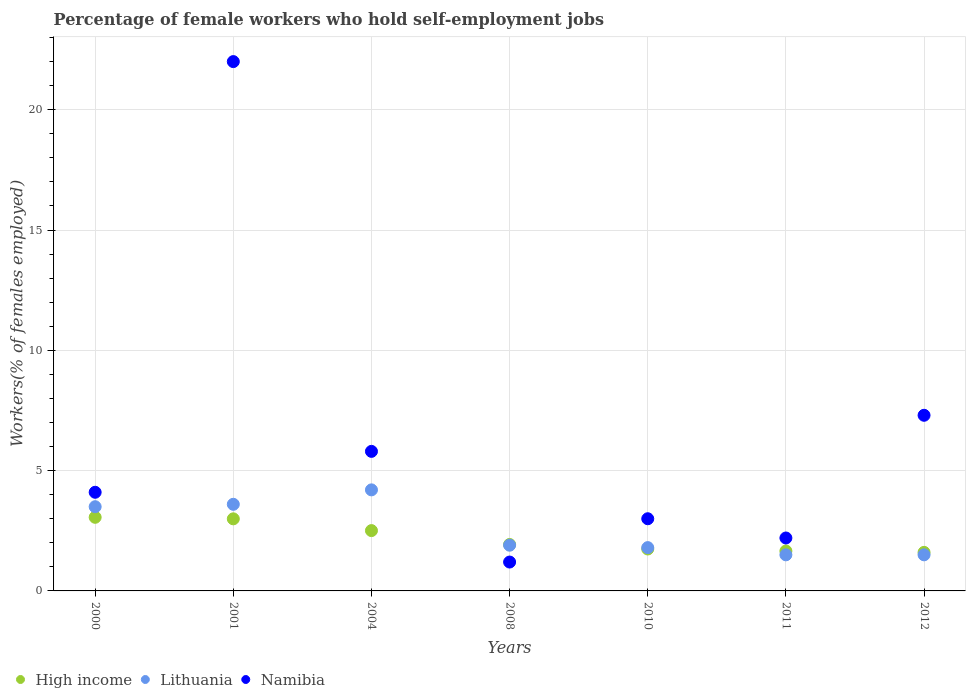What is the percentage of self-employed female workers in High income in 2010?
Provide a succinct answer. 1.74. Across all years, what is the maximum percentage of self-employed female workers in Lithuania?
Keep it short and to the point. 4.2. What is the total percentage of self-employed female workers in Lithuania in the graph?
Your response must be concise. 18. What is the difference between the percentage of self-employed female workers in High income in 2000 and that in 2010?
Give a very brief answer. 1.32. What is the difference between the percentage of self-employed female workers in Lithuania in 2008 and the percentage of self-employed female workers in High income in 2010?
Provide a short and direct response. 0.16. What is the average percentage of self-employed female workers in Lithuania per year?
Make the answer very short. 2.57. In the year 2000, what is the difference between the percentage of self-employed female workers in Lithuania and percentage of self-employed female workers in Namibia?
Provide a succinct answer. -0.6. In how many years, is the percentage of self-employed female workers in Lithuania greater than 13 %?
Give a very brief answer. 0. What is the ratio of the percentage of self-employed female workers in Lithuania in 2000 to that in 2001?
Give a very brief answer. 0.97. What is the difference between the highest and the second highest percentage of self-employed female workers in High income?
Offer a very short reply. 0.06. What is the difference between the highest and the lowest percentage of self-employed female workers in Namibia?
Provide a short and direct response. 20.8. Is it the case that in every year, the sum of the percentage of self-employed female workers in Namibia and percentage of self-employed female workers in High income  is greater than the percentage of self-employed female workers in Lithuania?
Ensure brevity in your answer.  Yes. Does the percentage of self-employed female workers in High income monotonically increase over the years?
Offer a very short reply. No. Is the percentage of self-employed female workers in Namibia strictly greater than the percentage of self-employed female workers in High income over the years?
Ensure brevity in your answer.  No. Are the values on the major ticks of Y-axis written in scientific E-notation?
Offer a terse response. No. Does the graph contain any zero values?
Provide a short and direct response. No. What is the title of the graph?
Your answer should be compact. Percentage of female workers who hold self-employment jobs. What is the label or title of the X-axis?
Offer a very short reply. Years. What is the label or title of the Y-axis?
Your answer should be very brief. Workers(% of females employed). What is the Workers(% of females employed) in High income in 2000?
Offer a terse response. 3.06. What is the Workers(% of females employed) of Namibia in 2000?
Give a very brief answer. 4.1. What is the Workers(% of females employed) of High income in 2001?
Your answer should be very brief. 3. What is the Workers(% of females employed) of Lithuania in 2001?
Make the answer very short. 3.6. What is the Workers(% of females employed) in High income in 2004?
Make the answer very short. 2.51. What is the Workers(% of females employed) in Lithuania in 2004?
Offer a terse response. 4.2. What is the Workers(% of females employed) in Namibia in 2004?
Provide a succinct answer. 5.8. What is the Workers(% of females employed) of High income in 2008?
Provide a succinct answer. 1.93. What is the Workers(% of females employed) of Lithuania in 2008?
Keep it short and to the point. 1.9. What is the Workers(% of females employed) in Namibia in 2008?
Provide a succinct answer. 1.2. What is the Workers(% of females employed) in High income in 2010?
Give a very brief answer. 1.74. What is the Workers(% of females employed) of Lithuania in 2010?
Provide a succinct answer. 1.8. What is the Workers(% of females employed) in High income in 2011?
Keep it short and to the point. 1.66. What is the Workers(% of females employed) of Lithuania in 2011?
Offer a very short reply. 1.5. What is the Workers(% of females employed) of Namibia in 2011?
Provide a short and direct response. 2.2. What is the Workers(% of females employed) in High income in 2012?
Your response must be concise. 1.6. What is the Workers(% of females employed) in Lithuania in 2012?
Your answer should be compact. 1.5. What is the Workers(% of females employed) in Namibia in 2012?
Your answer should be compact. 7.3. Across all years, what is the maximum Workers(% of females employed) of High income?
Give a very brief answer. 3.06. Across all years, what is the maximum Workers(% of females employed) of Lithuania?
Make the answer very short. 4.2. Across all years, what is the minimum Workers(% of females employed) in High income?
Make the answer very short. 1.6. Across all years, what is the minimum Workers(% of females employed) of Namibia?
Offer a very short reply. 1.2. What is the total Workers(% of females employed) in High income in the graph?
Your answer should be very brief. 15.5. What is the total Workers(% of females employed) of Lithuania in the graph?
Offer a very short reply. 18. What is the total Workers(% of females employed) of Namibia in the graph?
Provide a short and direct response. 45.6. What is the difference between the Workers(% of females employed) in High income in 2000 and that in 2001?
Keep it short and to the point. 0.06. What is the difference between the Workers(% of females employed) of Lithuania in 2000 and that in 2001?
Provide a succinct answer. -0.1. What is the difference between the Workers(% of females employed) of Namibia in 2000 and that in 2001?
Make the answer very short. -17.9. What is the difference between the Workers(% of females employed) in High income in 2000 and that in 2004?
Make the answer very short. 0.55. What is the difference between the Workers(% of females employed) of Namibia in 2000 and that in 2004?
Your response must be concise. -1.7. What is the difference between the Workers(% of females employed) in High income in 2000 and that in 2008?
Offer a terse response. 1.13. What is the difference between the Workers(% of females employed) in Lithuania in 2000 and that in 2008?
Offer a very short reply. 1.6. What is the difference between the Workers(% of females employed) of Namibia in 2000 and that in 2008?
Offer a terse response. 2.9. What is the difference between the Workers(% of females employed) of High income in 2000 and that in 2010?
Give a very brief answer. 1.32. What is the difference between the Workers(% of females employed) of Lithuania in 2000 and that in 2010?
Your response must be concise. 1.7. What is the difference between the Workers(% of females employed) of Namibia in 2000 and that in 2010?
Offer a terse response. 1.1. What is the difference between the Workers(% of females employed) in High income in 2000 and that in 2011?
Keep it short and to the point. 1.4. What is the difference between the Workers(% of females employed) of High income in 2000 and that in 2012?
Provide a short and direct response. 1.46. What is the difference between the Workers(% of females employed) of Lithuania in 2000 and that in 2012?
Offer a terse response. 2. What is the difference between the Workers(% of females employed) in High income in 2001 and that in 2004?
Your answer should be compact. 0.49. What is the difference between the Workers(% of females employed) of Namibia in 2001 and that in 2004?
Make the answer very short. 16.2. What is the difference between the Workers(% of females employed) of High income in 2001 and that in 2008?
Offer a very short reply. 1.07. What is the difference between the Workers(% of females employed) in Lithuania in 2001 and that in 2008?
Make the answer very short. 1.7. What is the difference between the Workers(% of females employed) of Namibia in 2001 and that in 2008?
Give a very brief answer. 20.8. What is the difference between the Workers(% of females employed) of High income in 2001 and that in 2010?
Your answer should be compact. 1.25. What is the difference between the Workers(% of females employed) in Lithuania in 2001 and that in 2010?
Your response must be concise. 1.8. What is the difference between the Workers(% of females employed) in Namibia in 2001 and that in 2010?
Offer a terse response. 19. What is the difference between the Workers(% of females employed) in High income in 2001 and that in 2011?
Provide a short and direct response. 1.34. What is the difference between the Workers(% of females employed) in Lithuania in 2001 and that in 2011?
Keep it short and to the point. 2.1. What is the difference between the Workers(% of females employed) in Namibia in 2001 and that in 2011?
Your response must be concise. 19.8. What is the difference between the Workers(% of females employed) in High income in 2001 and that in 2012?
Offer a terse response. 1.39. What is the difference between the Workers(% of females employed) of Namibia in 2001 and that in 2012?
Offer a very short reply. 14.7. What is the difference between the Workers(% of females employed) of High income in 2004 and that in 2008?
Your response must be concise. 0.58. What is the difference between the Workers(% of females employed) of High income in 2004 and that in 2010?
Your response must be concise. 0.76. What is the difference between the Workers(% of females employed) of High income in 2004 and that in 2011?
Your answer should be compact. 0.85. What is the difference between the Workers(% of females employed) in Namibia in 2004 and that in 2011?
Give a very brief answer. 3.6. What is the difference between the Workers(% of females employed) in High income in 2004 and that in 2012?
Give a very brief answer. 0.9. What is the difference between the Workers(% of females employed) of High income in 2008 and that in 2010?
Your answer should be compact. 0.19. What is the difference between the Workers(% of females employed) in High income in 2008 and that in 2011?
Keep it short and to the point. 0.27. What is the difference between the Workers(% of females employed) in Lithuania in 2008 and that in 2011?
Provide a short and direct response. 0.4. What is the difference between the Workers(% of females employed) in High income in 2008 and that in 2012?
Provide a succinct answer. 0.33. What is the difference between the Workers(% of females employed) of High income in 2010 and that in 2011?
Give a very brief answer. 0.08. What is the difference between the Workers(% of females employed) in Lithuania in 2010 and that in 2011?
Ensure brevity in your answer.  0.3. What is the difference between the Workers(% of females employed) of High income in 2010 and that in 2012?
Offer a terse response. 0.14. What is the difference between the Workers(% of females employed) in Lithuania in 2010 and that in 2012?
Your response must be concise. 0.3. What is the difference between the Workers(% of females employed) in Namibia in 2010 and that in 2012?
Make the answer very short. -4.3. What is the difference between the Workers(% of females employed) in High income in 2011 and that in 2012?
Provide a succinct answer. 0.06. What is the difference between the Workers(% of females employed) of High income in 2000 and the Workers(% of females employed) of Lithuania in 2001?
Provide a succinct answer. -0.54. What is the difference between the Workers(% of females employed) of High income in 2000 and the Workers(% of females employed) of Namibia in 2001?
Offer a terse response. -18.94. What is the difference between the Workers(% of females employed) of Lithuania in 2000 and the Workers(% of females employed) of Namibia in 2001?
Give a very brief answer. -18.5. What is the difference between the Workers(% of females employed) of High income in 2000 and the Workers(% of females employed) of Lithuania in 2004?
Give a very brief answer. -1.14. What is the difference between the Workers(% of females employed) of High income in 2000 and the Workers(% of females employed) of Namibia in 2004?
Keep it short and to the point. -2.74. What is the difference between the Workers(% of females employed) in Lithuania in 2000 and the Workers(% of females employed) in Namibia in 2004?
Give a very brief answer. -2.3. What is the difference between the Workers(% of females employed) of High income in 2000 and the Workers(% of females employed) of Lithuania in 2008?
Offer a terse response. 1.16. What is the difference between the Workers(% of females employed) of High income in 2000 and the Workers(% of females employed) of Namibia in 2008?
Offer a terse response. 1.86. What is the difference between the Workers(% of females employed) in High income in 2000 and the Workers(% of females employed) in Lithuania in 2010?
Give a very brief answer. 1.26. What is the difference between the Workers(% of females employed) of High income in 2000 and the Workers(% of females employed) of Namibia in 2010?
Your response must be concise. 0.06. What is the difference between the Workers(% of females employed) in Lithuania in 2000 and the Workers(% of females employed) in Namibia in 2010?
Ensure brevity in your answer.  0.5. What is the difference between the Workers(% of females employed) of High income in 2000 and the Workers(% of females employed) of Lithuania in 2011?
Your response must be concise. 1.56. What is the difference between the Workers(% of females employed) of High income in 2000 and the Workers(% of females employed) of Namibia in 2011?
Offer a terse response. 0.86. What is the difference between the Workers(% of females employed) in High income in 2000 and the Workers(% of females employed) in Lithuania in 2012?
Your answer should be compact. 1.56. What is the difference between the Workers(% of females employed) in High income in 2000 and the Workers(% of females employed) in Namibia in 2012?
Ensure brevity in your answer.  -4.24. What is the difference between the Workers(% of females employed) of Lithuania in 2000 and the Workers(% of females employed) of Namibia in 2012?
Provide a succinct answer. -3.8. What is the difference between the Workers(% of females employed) of High income in 2001 and the Workers(% of females employed) of Lithuania in 2004?
Keep it short and to the point. -1.2. What is the difference between the Workers(% of females employed) of High income in 2001 and the Workers(% of females employed) of Namibia in 2004?
Keep it short and to the point. -2.8. What is the difference between the Workers(% of females employed) in High income in 2001 and the Workers(% of females employed) in Lithuania in 2008?
Make the answer very short. 1.1. What is the difference between the Workers(% of females employed) in High income in 2001 and the Workers(% of females employed) in Namibia in 2008?
Provide a succinct answer. 1.8. What is the difference between the Workers(% of females employed) in Lithuania in 2001 and the Workers(% of females employed) in Namibia in 2008?
Make the answer very short. 2.4. What is the difference between the Workers(% of females employed) of High income in 2001 and the Workers(% of females employed) of Lithuania in 2010?
Provide a succinct answer. 1.2. What is the difference between the Workers(% of females employed) in High income in 2001 and the Workers(% of females employed) in Namibia in 2010?
Offer a very short reply. -0. What is the difference between the Workers(% of females employed) in Lithuania in 2001 and the Workers(% of females employed) in Namibia in 2010?
Provide a succinct answer. 0.6. What is the difference between the Workers(% of females employed) of High income in 2001 and the Workers(% of females employed) of Lithuania in 2011?
Provide a succinct answer. 1.5. What is the difference between the Workers(% of females employed) of High income in 2001 and the Workers(% of females employed) of Namibia in 2011?
Make the answer very short. 0.8. What is the difference between the Workers(% of females employed) in Lithuania in 2001 and the Workers(% of females employed) in Namibia in 2011?
Give a very brief answer. 1.4. What is the difference between the Workers(% of females employed) of High income in 2001 and the Workers(% of females employed) of Lithuania in 2012?
Offer a terse response. 1.5. What is the difference between the Workers(% of females employed) of High income in 2001 and the Workers(% of females employed) of Namibia in 2012?
Your response must be concise. -4.3. What is the difference between the Workers(% of females employed) of High income in 2004 and the Workers(% of females employed) of Lithuania in 2008?
Your response must be concise. 0.61. What is the difference between the Workers(% of females employed) in High income in 2004 and the Workers(% of females employed) in Namibia in 2008?
Your response must be concise. 1.31. What is the difference between the Workers(% of females employed) in Lithuania in 2004 and the Workers(% of females employed) in Namibia in 2008?
Make the answer very short. 3. What is the difference between the Workers(% of females employed) of High income in 2004 and the Workers(% of females employed) of Lithuania in 2010?
Offer a terse response. 0.71. What is the difference between the Workers(% of females employed) of High income in 2004 and the Workers(% of females employed) of Namibia in 2010?
Your answer should be very brief. -0.49. What is the difference between the Workers(% of females employed) of Lithuania in 2004 and the Workers(% of females employed) of Namibia in 2010?
Keep it short and to the point. 1.2. What is the difference between the Workers(% of females employed) in High income in 2004 and the Workers(% of females employed) in Lithuania in 2011?
Keep it short and to the point. 1.01. What is the difference between the Workers(% of females employed) of High income in 2004 and the Workers(% of females employed) of Namibia in 2011?
Ensure brevity in your answer.  0.31. What is the difference between the Workers(% of females employed) in Lithuania in 2004 and the Workers(% of females employed) in Namibia in 2011?
Your response must be concise. 2. What is the difference between the Workers(% of females employed) in High income in 2004 and the Workers(% of females employed) in Namibia in 2012?
Your answer should be very brief. -4.79. What is the difference between the Workers(% of females employed) of High income in 2008 and the Workers(% of females employed) of Lithuania in 2010?
Provide a succinct answer. 0.13. What is the difference between the Workers(% of females employed) in High income in 2008 and the Workers(% of females employed) in Namibia in 2010?
Your answer should be very brief. -1.07. What is the difference between the Workers(% of females employed) of Lithuania in 2008 and the Workers(% of females employed) of Namibia in 2010?
Provide a succinct answer. -1.1. What is the difference between the Workers(% of females employed) of High income in 2008 and the Workers(% of females employed) of Lithuania in 2011?
Ensure brevity in your answer.  0.43. What is the difference between the Workers(% of females employed) of High income in 2008 and the Workers(% of females employed) of Namibia in 2011?
Offer a very short reply. -0.27. What is the difference between the Workers(% of females employed) in Lithuania in 2008 and the Workers(% of females employed) in Namibia in 2011?
Provide a succinct answer. -0.3. What is the difference between the Workers(% of females employed) in High income in 2008 and the Workers(% of females employed) in Lithuania in 2012?
Offer a terse response. 0.43. What is the difference between the Workers(% of females employed) in High income in 2008 and the Workers(% of females employed) in Namibia in 2012?
Offer a terse response. -5.37. What is the difference between the Workers(% of females employed) of High income in 2010 and the Workers(% of females employed) of Lithuania in 2011?
Provide a short and direct response. 0.24. What is the difference between the Workers(% of females employed) in High income in 2010 and the Workers(% of females employed) in Namibia in 2011?
Keep it short and to the point. -0.46. What is the difference between the Workers(% of females employed) of High income in 2010 and the Workers(% of females employed) of Lithuania in 2012?
Offer a terse response. 0.24. What is the difference between the Workers(% of females employed) of High income in 2010 and the Workers(% of females employed) of Namibia in 2012?
Provide a succinct answer. -5.56. What is the difference between the Workers(% of females employed) in High income in 2011 and the Workers(% of females employed) in Lithuania in 2012?
Keep it short and to the point. 0.16. What is the difference between the Workers(% of females employed) in High income in 2011 and the Workers(% of females employed) in Namibia in 2012?
Provide a succinct answer. -5.64. What is the difference between the Workers(% of females employed) of Lithuania in 2011 and the Workers(% of females employed) of Namibia in 2012?
Provide a succinct answer. -5.8. What is the average Workers(% of females employed) in High income per year?
Offer a terse response. 2.21. What is the average Workers(% of females employed) of Lithuania per year?
Your answer should be compact. 2.57. What is the average Workers(% of females employed) of Namibia per year?
Your answer should be very brief. 6.51. In the year 2000, what is the difference between the Workers(% of females employed) in High income and Workers(% of females employed) in Lithuania?
Offer a very short reply. -0.44. In the year 2000, what is the difference between the Workers(% of females employed) in High income and Workers(% of females employed) in Namibia?
Make the answer very short. -1.04. In the year 2001, what is the difference between the Workers(% of females employed) of High income and Workers(% of females employed) of Lithuania?
Provide a short and direct response. -0.6. In the year 2001, what is the difference between the Workers(% of females employed) of High income and Workers(% of females employed) of Namibia?
Ensure brevity in your answer.  -19. In the year 2001, what is the difference between the Workers(% of females employed) in Lithuania and Workers(% of females employed) in Namibia?
Your answer should be very brief. -18.4. In the year 2004, what is the difference between the Workers(% of females employed) of High income and Workers(% of females employed) of Lithuania?
Provide a short and direct response. -1.69. In the year 2004, what is the difference between the Workers(% of females employed) in High income and Workers(% of females employed) in Namibia?
Keep it short and to the point. -3.29. In the year 2008, what is the difference between the Workers(% of females employed) of High income and Workers(% of females employed) of Lithuania?
Offer a terse response. 0.03. In the year 2008, what is the difference between the Workers(% of females employed) of High income and Workers(% of females employed) of Namibia?
Provide a short and direct response. 0.73. In the year 2008, what is the difference between the Workers(% of females employed) in Lithuania and Workers(% of females employed) in Namibia?
Offer a terse response. 0.7. In the year 2010, what is the difference between the Workers(% of females employed) of High income and Workers(% of females employed) of Lithuania?
Offer a terse response. -0.06. In the year 2010, what is the difference between the Workers(% of females employed) in High income and Workers(% of females employed) in Namibia?
Make the answer very short. -1.26. In the year 2010, what is the difference between the Workers(% of females employed) in Lithuania and Workers(% of females employed) in Namibia?
Provide a succinct answer. -1.2. In the year 2011, what is the difference between the Workers(% of females employed) in High income and Workers(% of females employed) in Lithuania?
Your response must be concise. 0.16. In the year 2011, what is the difference between the Workers(% of females employed) in High income and Workers(% of females employed) in Namibia?
Your answer should be very brief. -0.54. In the year 2012, what is the difference between the Workers(% of females employed) of High income and Workers(% of females employed) of Lithuania?
Offer a very short reply. 0.1. In the year 2012, what is the difference between the Workers(% of females employed) in High income and Workers(% of females employed) in Namibia?
Provide a short and direct response. -5.7. In the year 2012, what is the difference between the Workers(% of females employed) in Lithuania and Workers(% of females employed) in Namibia?
Offer a very short reply. -5.8. What is the ratio of the Workers(% of females employed) in High income in 2000 to that in 2001?
Ensure brevity in your answer.  1.02. What is the ratio of the Workers(% of females employed) of Lithuania in 2000 to that in 2001?
Offer a very short reply. 0.97. What is the ratio of the Workers(% of females employed) of Namibia in 2000 to that in 2001?
Your response must be concise. 0.19. What is the ratio of the Workers(% of females employed) of High income in 2000 to that in 2004?
Your response must be concise. 1.22. What is the ratio of the Workers(% of females employed) in Lithuania in 2000 to that in 2004?
Your response must be concise. 0.83. What is the ratio of the Workers(% of females employed) in Namibia in 2000 to that in 2004?
Provide a succinct answer. 0.71. What is the ratio of the Workers(% of females employed) of High income in 2000 to that in 2008?
Give a very brief answer. 1.59. What is the ratio of the Workers(% of females employed) of Lithuania in 2000 to that in 2008?
Ensure brevity in your answer.  1.84. What is the ratio of the Workers(% of females employed) of Namibia in 2000 to that in 2008?
Your answer should be compact. 3.42. What is the ratio of the Workers(% of females employed) in High income in 2000 to that in 2010?
Offer a very short reply. 1.76. What is the ratio of the Workers(% of females employed) of Lithuania in 2000 to that in 2010?
Offer a very short reply. 1.94. What is the ratio of the Workers(% of females employed) of Namibia in 2000 to that in 2010?
Your answer should be very brief. 1.37. What is the ratio of the Workers(% of females employed) in High income in 2000 to that in 2011?
Give a very brief answer. 1.84. What is the ratio of the Workers(% of females employed) in Lithuania in 2000 to that in 2011?
Your answer should be compact. 2.33. What is the ratio of the Workers(% of females employed) of Namibia in 2000 to that in 2011?
Offer a very short reply. 1.86. What is the ratio of the Workers(% of females employed) in High income in 2000 to that in 2012?
Provide a succinct answer. 1.91. What is the ratio of the Workers(% of females employed) of Lithuania in 2000 to that in 2012?
Your answer should be compact. 2.33. What is the ratio of the Workers(% of females employed) of Namibia in 2000 to that in 2012?
Keep it short and to the point. 0.56. What is the ratio of the Workers(% of females employed) of High income in 2001 to that in 2004?
Offer a very short reply. 1.2. What is the ratio of the Workers(% of females employed) of Namibia in 2001 to that in 2004?
Provide a succinct answer. 3.79. What is the ratio of the Workers(% of females employed) in High income in 2001 to that in 2008?
Keep it short and to the point. 1.55. What is the ratio of the Workers(% of females employed) of Lithuania in 2001 to that in 2008?
Your response must be concise. 1.89. What is the ratio of the Workers(% of females employed) of Namibia in 2001 to that in 2008?
Ensure brevity in your answer.  18.33. What is the ratio of the Workers(% of females employed) in High income in 2001 to that in 2010?
Offer a very short reply. 1.72. What is the ratio of the Workers(% of females employed) of Namibia in 2001 to that in 2010?
Offer a very short reply. 7.33. What is the ratio of the Workers(% of females employed) in High income in 2001 to that in 2011?
Provide a succinct answer. 1.81. What is the ratio of the Workers(% of females employed) in High income in 2001 to that in 2012?
Offer a terse response. 1.87. What is the ratio of the Workers(% of females employed) of Lithuania in 2001 to that in 2012?
Provide a succinct answer. 2.4. What is the ratio of the Workers(% of females employed) of Namibia in 2001 to that in 2012?
Keep it short and to the point. 3.01. What is the ratio of the Workers(% of females employed) in High income in 2004 to that in 2008?
Offer a terse response. 1.3. What is the ratio of the Workers(% of females employed) of Lithuania in 2004 to that in 2008?
Make the answer very short. 2.21. What is the ratio of the Workers(% of females employed) of Namibia in 2004 to that in 2008?
Offer a terse response. 4.83. What is the ratio of the Workers(% of females employed) in High income in 2004 to that in 2010?
Make the answer very short. 1.44. What is the ratio of the Workers(% of females employed) in Lithuania in 2004 to that in 2010?
Give a very brief answer. 2.33. What is the ratio of the Workers(% of females employed) in Namibia in 2004 to that in 2010?
Your response must be concise. 1.93. What is the ratio of the Workers(% of females employed) in High income in 2004 to that in 2011?
Give a very brief answer. 1.51. What is the ratio of the Workers(% of females employed) in Namibia in 2004 to that in 2011?
Offer a very short reply. 2.64. What is the ratio of the Workers(% of females employed) in High income in 2004 to that in 2012?
Your response must be concise. 1.56. What is the ratio of the Workers(% of females employed) of Lithuania in 2004 to that in 2012?
Your answer should be compact. 2.8. What is the ratio of the Workers(% of females employed) in Namibia in 2004 to that in 2012?
Provide a succinct answer. 0.79. What is the ratio of the Workers(% of females employed) of High income in 2008 to that in 2010?
Keep it short and to the point. 1.11. What is the ratio of the Workers(% of females employed) of Lithuania in 2008 to that in 2010?
Offer a very short reply. 1.06. What is the ratio of the Workers(% of females employed) of High income in 2008 to that in 2011?
Offer a terse response. 1.16. What is the ratio of the Workers(% of females employed) of Lithuania in 2008 to that in 2011?
Your response must be concise. 1.27. What is the ratio of the Workers(% of females employed) of Namibia in 2008 to that in 2011?
Ensure brevity in your answer.  0.55. What is the ratio of the Workers(% of females employed) of High income in 2008 to that in 2012?
Offer a terse response. 1.2. What is the ratio of the Workers(% of females employed) in Lithuania in 2008 to that in 2012?
Ensure brevity in your answer.  1.27. What is the ratio of the Workers(% of females employed) of Namibia in 2008 to that in 2012?
Your answer should be very brief. 0.16. What is the ratio of the Workers(% of females employed) of High income in 2010 to that in 2011?
Your answer should be compact. 1.05. What is the ratio of the Workers(% of females employed) in Lithuania in 2010 to that in 2011?
Provide a succinct answer. 1.2. What is the ratio of the Workers(% of females employed) in Namibia in 2010 to that in 2011?
Offer a very short reply. 1.36. What is the ratio of the Workers(% of females employed) of High income in 2010 to that in 2012?
Keep it short and to the point. 1.09. What is the ratio of the Workers(% of females employed) in Lithuania in 2010 to that in 2012?
Provide a succinct answer. 1.2. What is the ratio of the Workers(% of females employed) of Namibia in 2010 to that in 2012?
Your answer should be very brief. 0.41. What is the ratio of the Workers(% of females employed) in High income in 2011 to that in 2012?
Your answer should be very brief. 1.04. What is the ratio of the Workers(% of females employed) in Lithuania in 2011 to that in 2012?
Your answer should be compact. 1. What is the ratio of the Workers(% of females employed) of Namibia in 2011 to that in 2012?
Make the answer very short. 0.3. What is the difference between the highest and the second highest Workers(% of females employed) of High income?
Give a very brief answer. 0.06. What is the difference between the highest and the second highest Workers(% of females employed) in Namibia?
Your answer should be very brief. 14.7. What is the difference between the highest and the lowest Workers(% of females employed) of High income?
Offer a very short reply. 1.46. What is the difference between the highest and the lowest Workers(% of females employed) in Namibia?
Provide a succinct answer. 20.8. 